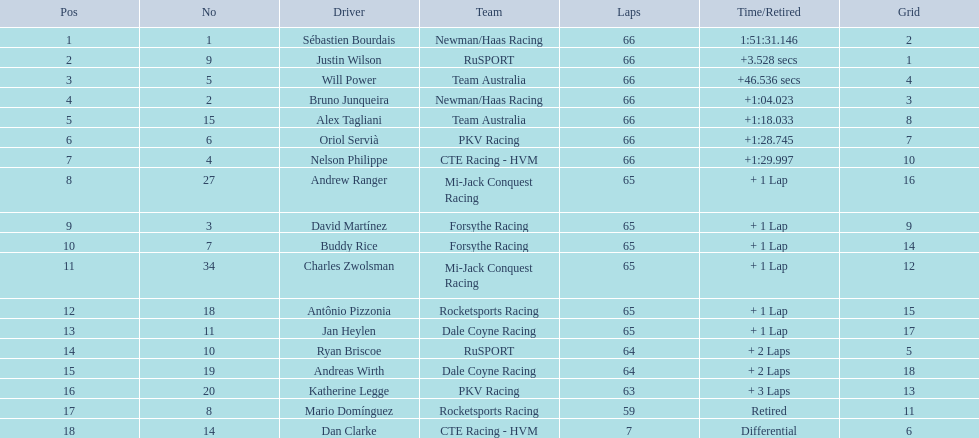Which drivers scored at least 10 points? Sébastien Bourdais, Justin Wilson, Will Power, Bruno Junqueira, Alex Tagliani, Oriol Servià, Nelson Philippe, Andrew Ranger, David Martínez, Buddy Rice, Charles Zwolsman. Of those drivers, which ones scored at least 20 points? Sébastien Bourdais, Justin Wilson, Will Power, Bruno Junqueira, Alex Tagliani. Of those 5, which driver scored the most points? Sébastien Bourdais. 